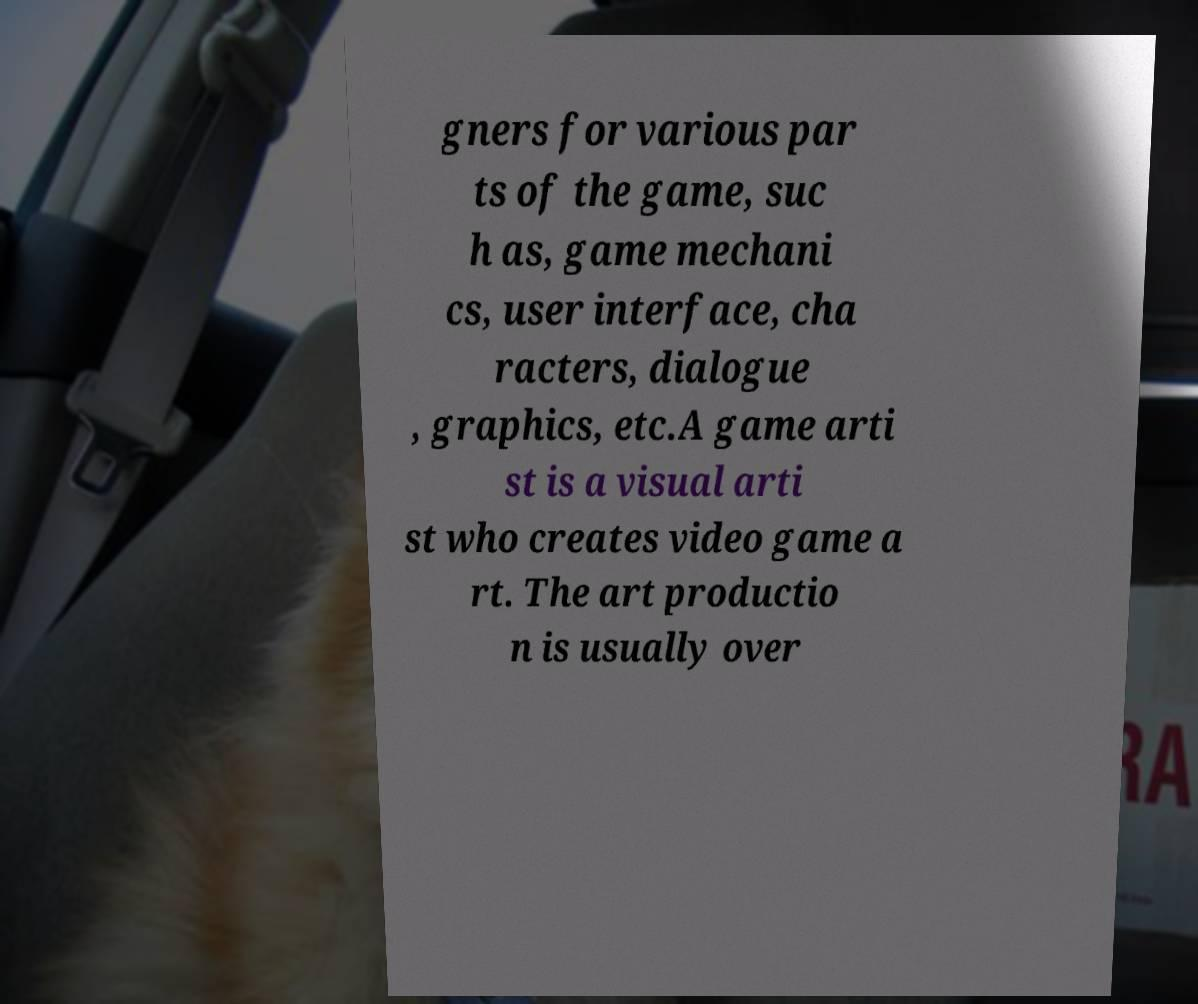Can you read and provide the text displayed in the image?This photo seems to have some interesting text. Can you extract and type it out for me? gners for various par ts of the game, suc h as, game mechani cs, user interface, cha racters, dialogue , graphics, etc.A game arti st is a visual arti st who creates video game a rt. The art productio n is usually over 